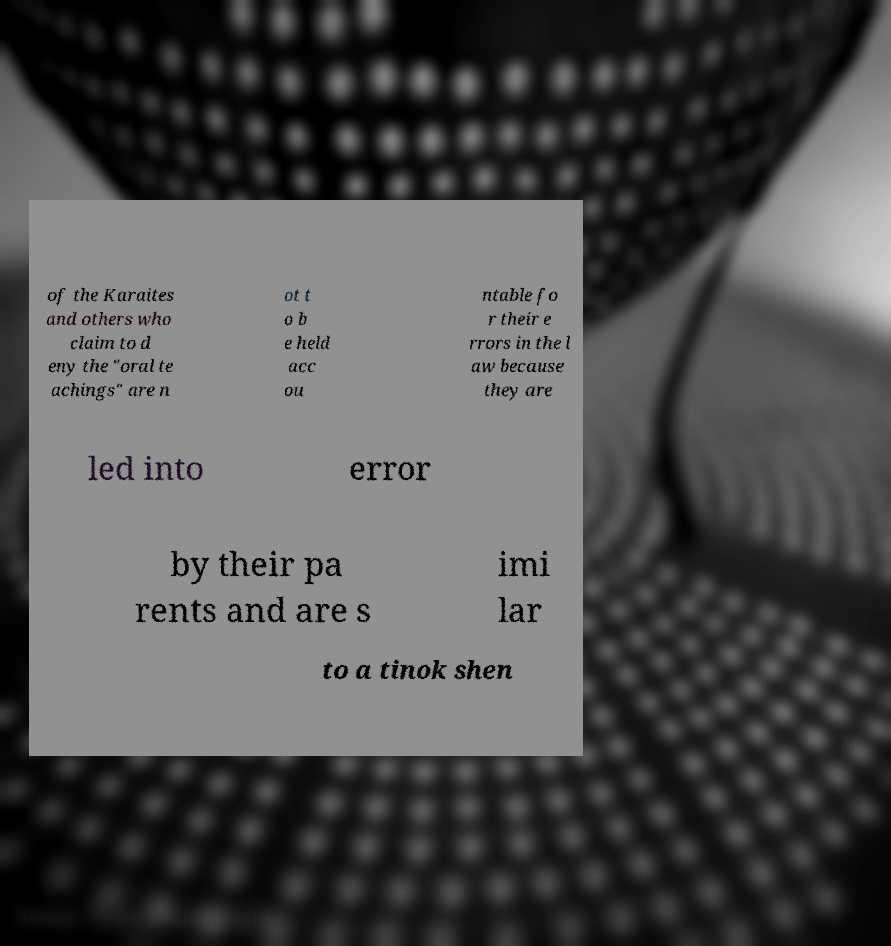I need the written content from this picture converted into text. Can you do that? of the Karaites and others who claim to d eny the "oral te achings" are n ot t o b e held acc ou ntable fo r their e rrors in the l aw because they are led into error by their pa rents and are s imi lar to a tinok shen 